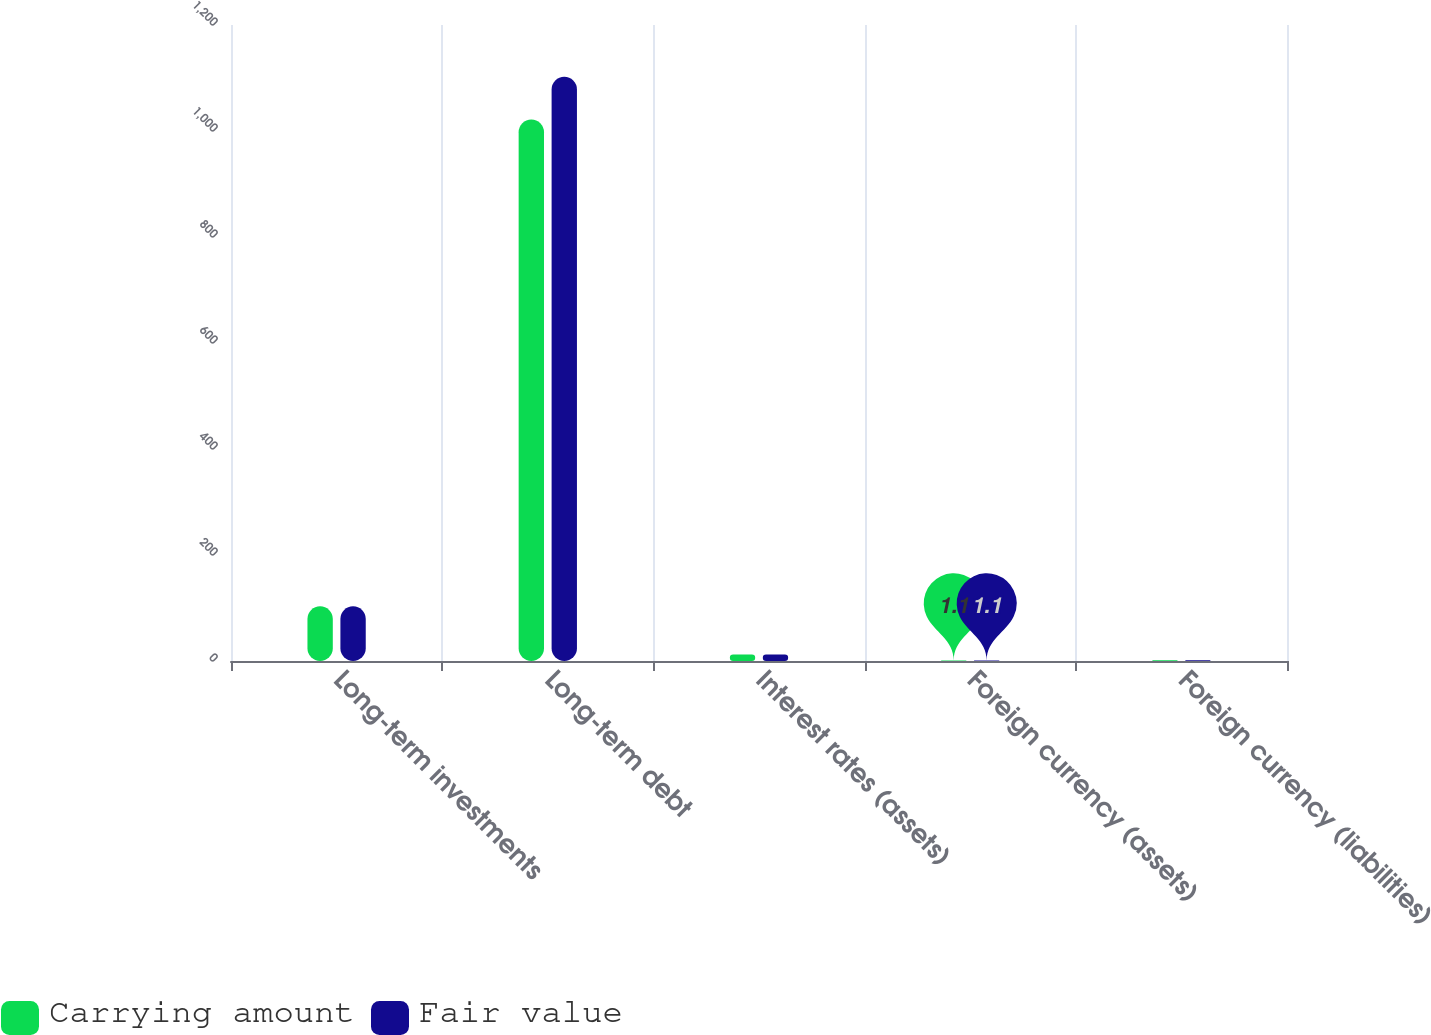<chart> <loc_0><loc_0><loc_500><loc_500><stacked_bar_chart><ecel><fcel>Long-term investments<fcel>Long-term debt<fcel>Interest rates (assets)<fcel>Foreign currency (assets)<fcel>Foreign currency (liabilities)<nl><fcel>Carrying amount<fcel>103.4<fcel>1021.5<fcel>12.2<fcel>1.1<fcel>1.6<nl><fcel>Fair value<fcel>103.4<fcel>1102.4<fcel>12.2<fcel>1.1<fcel>1.6<nl></chart> 